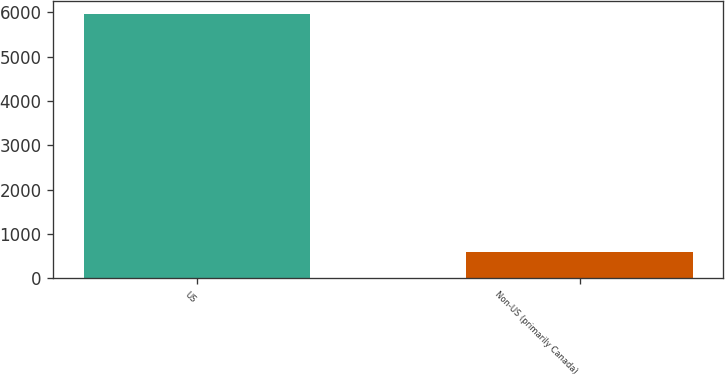Convert chart to OTSL. <chart><loc_0><loc_0><loc_500><loc_500><bar_chart><fcel>US<fcel>Non-US (primarily Canada)<nl><fcel>5960.9<fcel>587.5<nl></chart> 